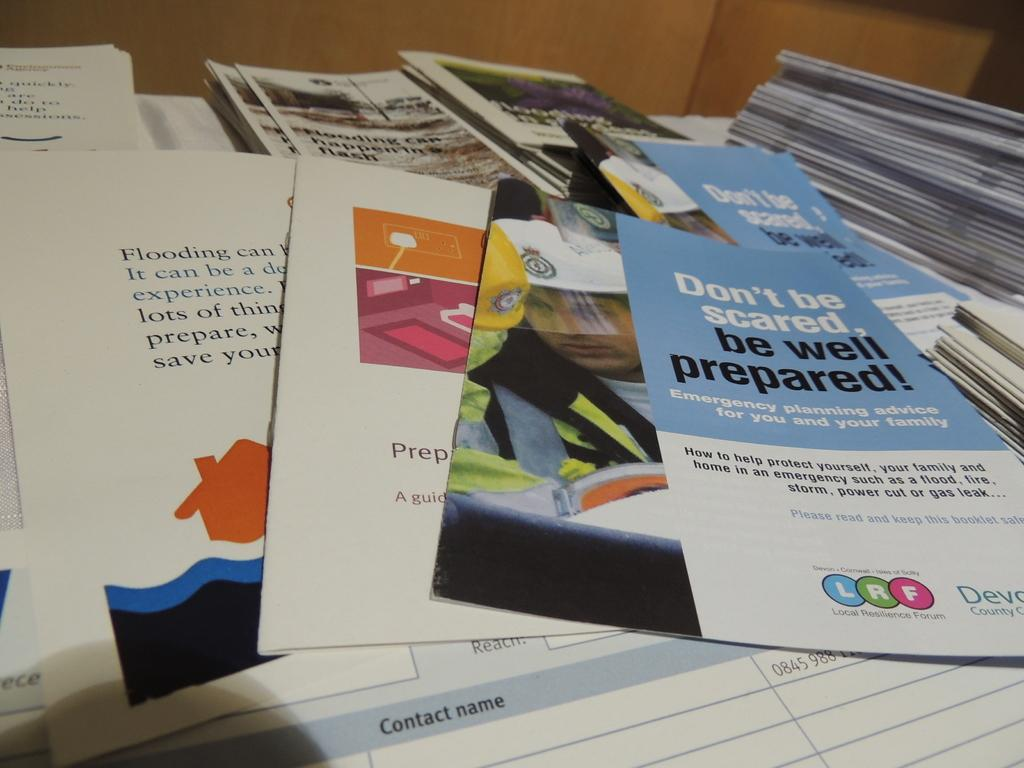What type of objects can be seen in the image? There are books and papers in the image. Can you describe the background of the image? There is a wall visible at the top of the image. What type of collar can be seen on the baby in the image? There is no baby or collar present in the image; it only features books, papers, and a wall. How many fish are visible in the image? There are no fish present in the image. 